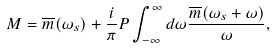Convert formula to latex. <formula><loc_0><loc_0><loc_500><loc_500>M = \overline { m } ( \omega _ { s } ) + \frac { i } { \pi } P \int _ { - \infty } ^ { \infty } d \omega \frac { \overline { m } ( \omega _ { s } + \omega ) } { \omega } ,</formula> 